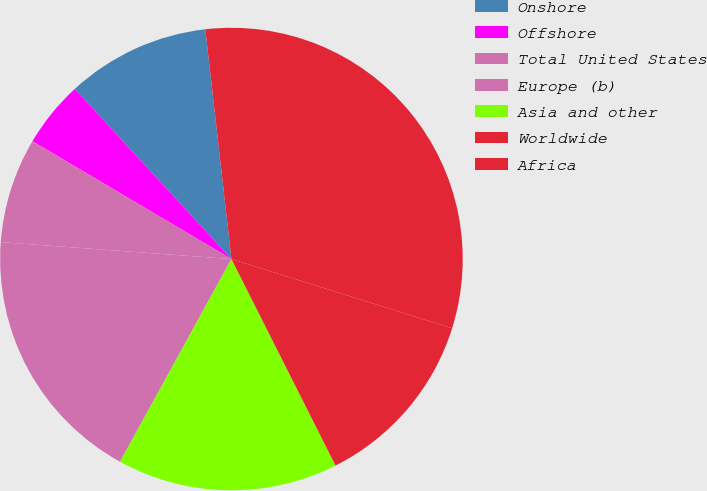<chart> <loc_0><loc_0><loc_500><loc_500><pie_chart><fcel>Onshore<fcel>Offshore<fcel>Total United States<fcel>Europe (b)<fcel>Asia and other<fcel>Worldwide<fcel>Africa<nl><fcel>10.04%<fcel>4.65%<fcel>7.34%<fcel>18.17%<fcel>15.43%<fcel>12.73%<fcel>31.64%<nl></chart> 